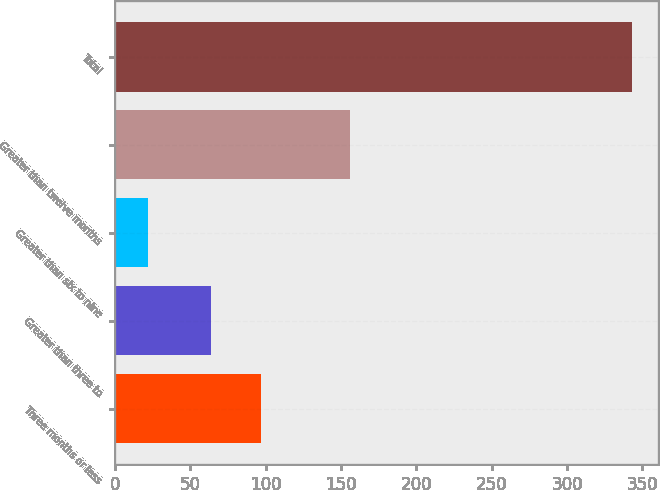Convert chart. <chart><loc_0><loc_0><loc_500><loc_500><bar_chart><fcel>Three months or less<fcel>Greater than three to<fcel>Greater than six to nine<fcel>Greater than twelve months<fcel>Total<nl><fcel>97<fcel>64<fcel>22<fcel>156<fcel>343<nl></chart> 